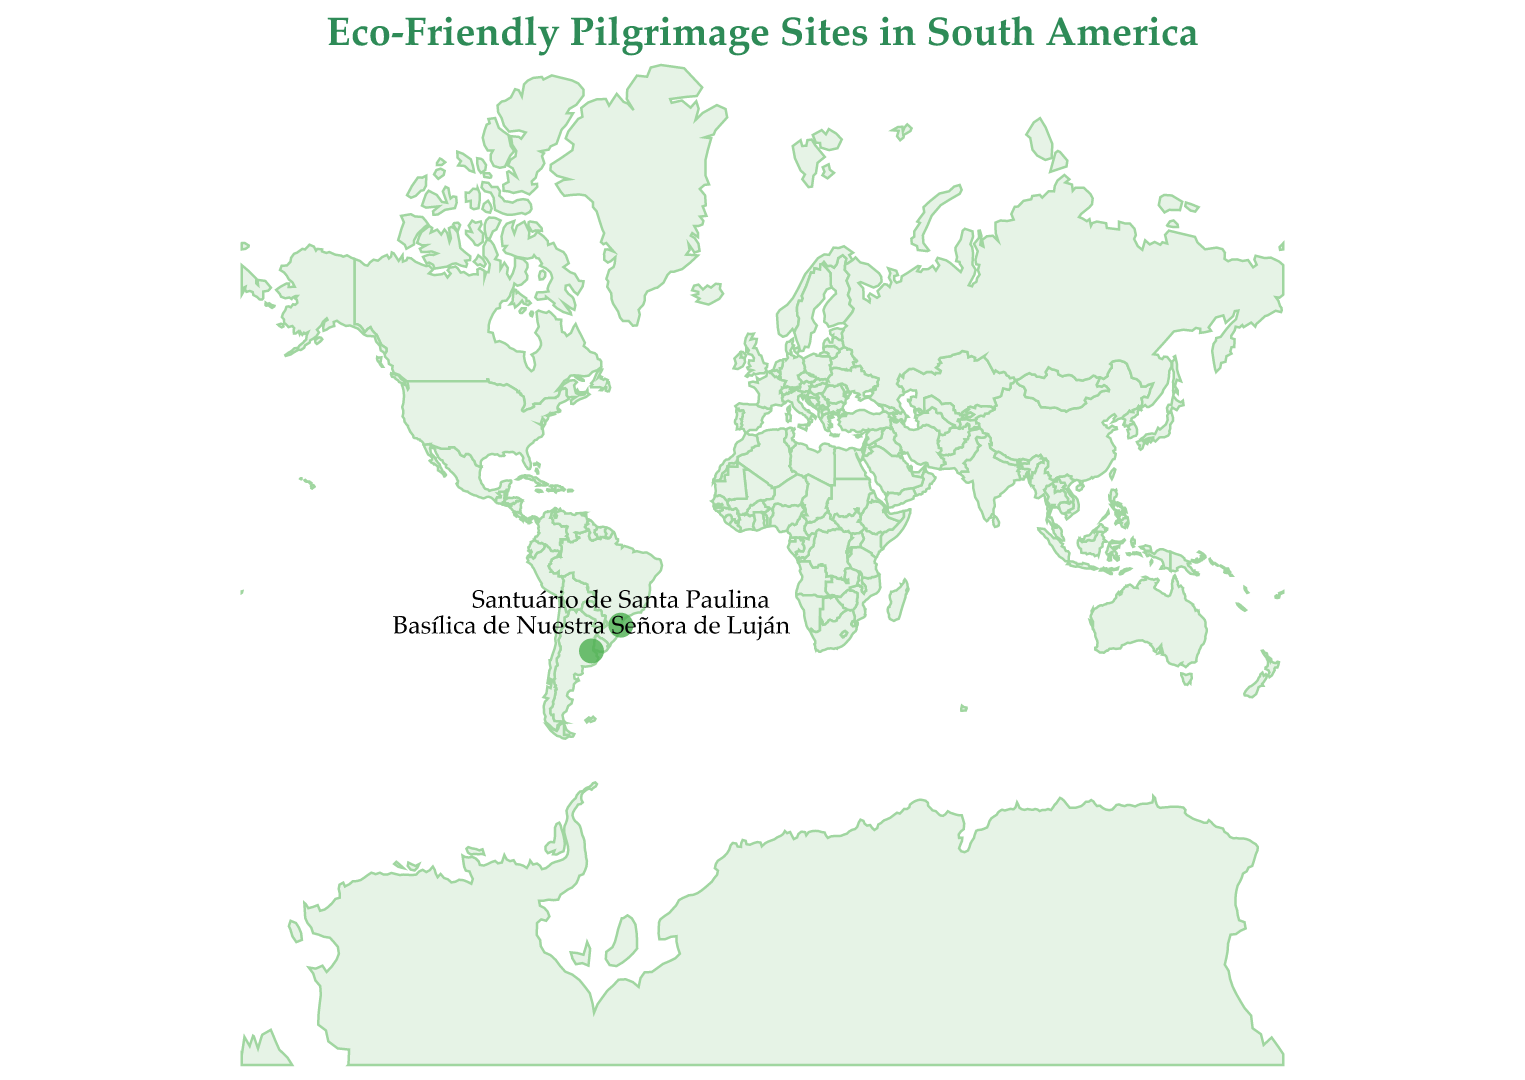What is the title of the plot? The title of a plot is usually found at the top and describes what the plot is about. In this case, it provides a general idea of the content related to eco-friendly pilgrimage sites in South America.
Answer: Eco-Friendly Pilgrimage Sites in South America How many data points are shown on the map? By examining the plot, we can count the number of circles, which represent the data points.
Answer: Two What are the types of sites shown in the plot? Each data point has a corresponding label describing its type. We can identify the types by looking at the plotted points and their tooltips or labels.
Answer: Pilgrimage Site, Eco-Pilgrimage Which site is located closer to the equator? To determine this, look at the latitude values of the sites. The site with a latitude closer to 0 degrees is nearer to the equator.
Answer: Santuário de Santa Paulina Compare the environmental focus of the two sites. By reading the descriptions associated with each site from the plot, we can compare their environmental initiatives.
Answer: Basílica de Nuestra Señora de Luján focuses on water conservation, while Santuário de Santa Paulina emphasizes organic gardens and environmental education What is the latitude and longitude of Santuário de Santa Paulina? Check the plotted point labeled 'Santuário de Santa Paulina' and note its latitude and longitude from the tooltip or label information.
Answer: Latitude: -26.9242, Longitude: -48.9572 Which country has both pilgrimage sites and eco-pilgrimages shown on the plot? By identifying the countries in the descriptions of the plotted points, we see that both types are present.
Answer: Brazil Identify the site with water conservation programs. This can be identified by the description attached to each site. Look for keywords related to water conservation in the site descriptions.
Answer: Basílica de Nuestra Señora de Luján What type of projection is used in this map? The projection type describes how the 3D surface of the earth is represented on a 2D plot. Check the plot's background details.
Answer: Mercator 